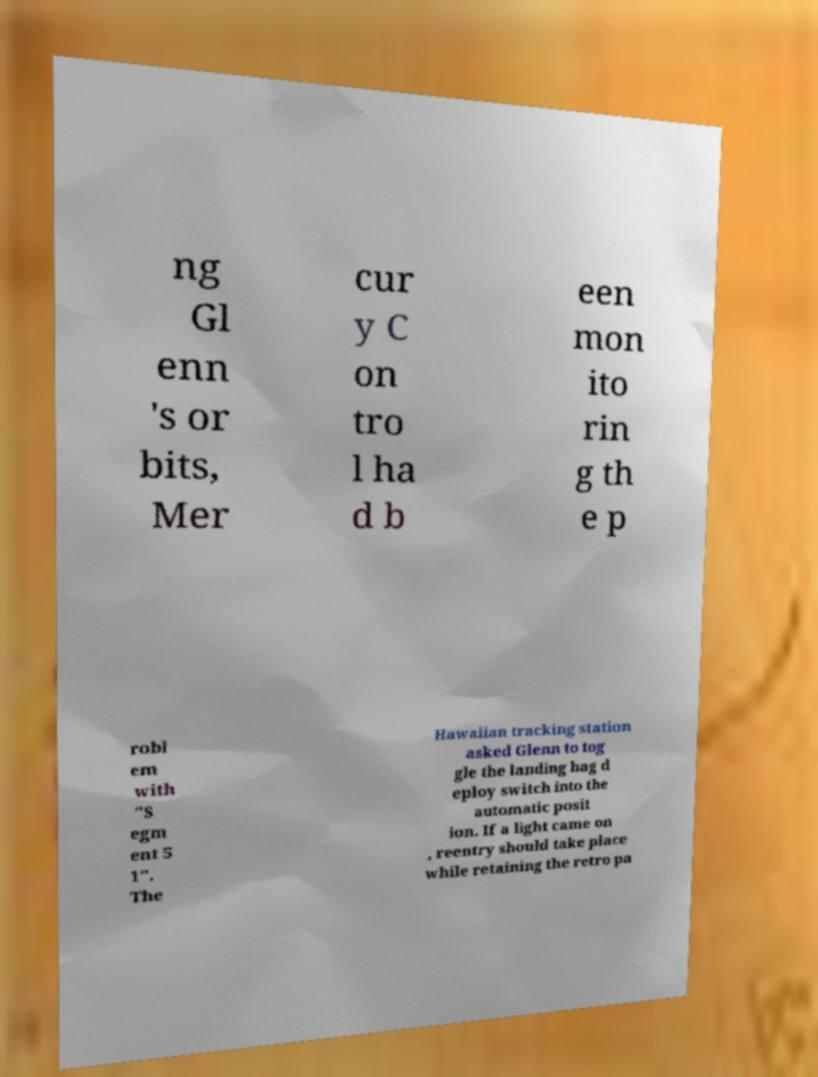Please identify and transcribe the text found in this image. ng Gl enn 's or bits, Mer cur y C on tro l ha d b een mon ito rin g th e p robl em with "S egm ent 5 1". The Hawaiian tracking station asked Glenn to tog gle the landing bag d eploy switch into the automatic posit ion. If a light came on , reentry should take place while retaining the retro pa 